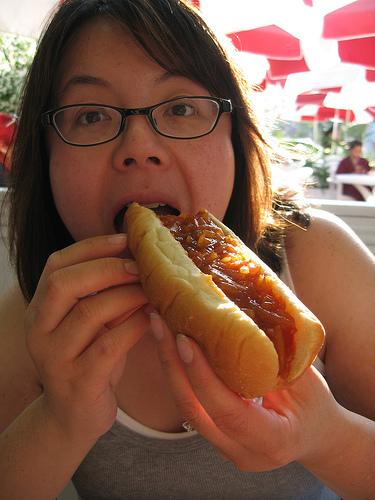Identify a referential expression connecting the hot dog and its holder. The hot dog and bun are in the woman's hand. For a visual entailment, create a statement that contradicts the given image description. The woman is not wearing any glasses and has no ring on her finger. Compose a brief product advertisement using elements from the image. Enjoy the juiciest, most delicious hot dogs, loaded with tasty toppings, at our outdoor cafe with comfortable seating and colorful red and white umbrellas! List the colors of the umbrellas in the background of the image. The umbrellas are red and white. Could you describe the toppings found on the hot dog? The hot dog has ketchup, onions, and a piece of yellow cheese on top. Choose a caption about a piece of jewelry the woman is wearing. The woman is wearing a diamond ring on her finger. In a multi-choice VQA task, what would be the accurate description of the woman's shirt? The woman is wearing a gray and white shirt. Mention an accessory that the woman is wearing on her face. The woman is wearing black-rimmed eyeglasses. Which object in the image has the most narrow image? The woman's diamond ring has the narrowest image. What is the woman in the image doing? The woman is about to bite a hot dog. 